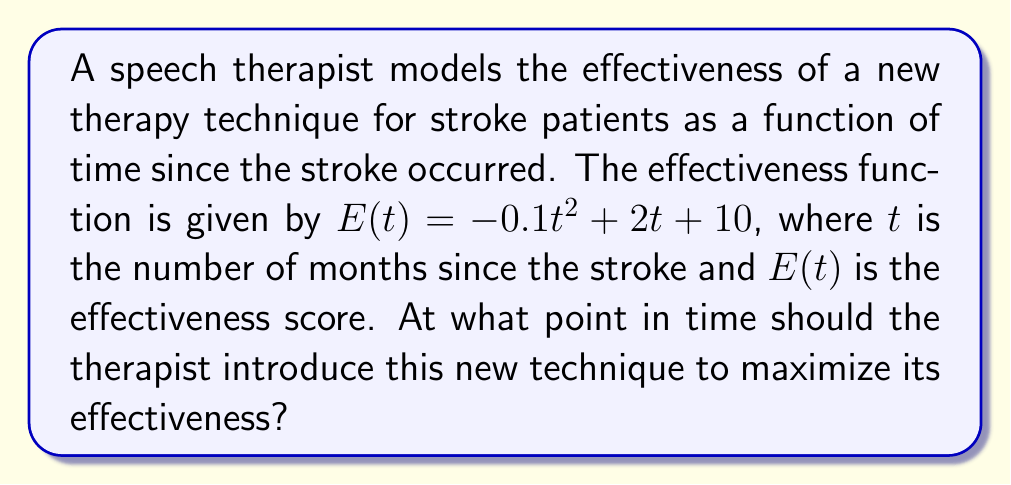Show me your answer to this math problem. To find the optimal timing for introducing the new speech therapy technique, we need to determine the maximum point of the effectiveness function $E(t)$. This can be done by following these steps:

1. The function $E(t) = -0.1t^2 + 2t + 10$ is a quadratic function, which forms a parabola.

2. To find the maximum point, we need to calculate the vertex of the parabola. For a quadratic function in the form $f(t) = at^2 + bt + c$, the t-coordinate of the vertex is given by $t = -\frac{b}{2a}$.

3. In our case, $a = -0.1$ and $b = 2$. Let's substitute these values:

   $t = -\frac{2}{2(-0.1)} = -\frac{2}{-0.2} = 10$

4. Therefore, the maximum effectiveness occurs at $t = 10$ months after the stroke.

5. To verify this is indeed a maximum (not a minimum), we can observe that $a = -0.1 < 0$, which means the parabola opens downward, confirming a maximum point.

6. We can calculate the maximum effectiveness score by plugging $t = 10$ into the original function:

   $E(10) = -0.1(10)^2 + 2(10) + 10 = -10 + 20 + 10 = 20$

Thus, the optimal time to introduce the new technique is 10 months after the stroke, when the effectiveness score reaches its maximum value of 20.
Answer: 10 months after stroke 